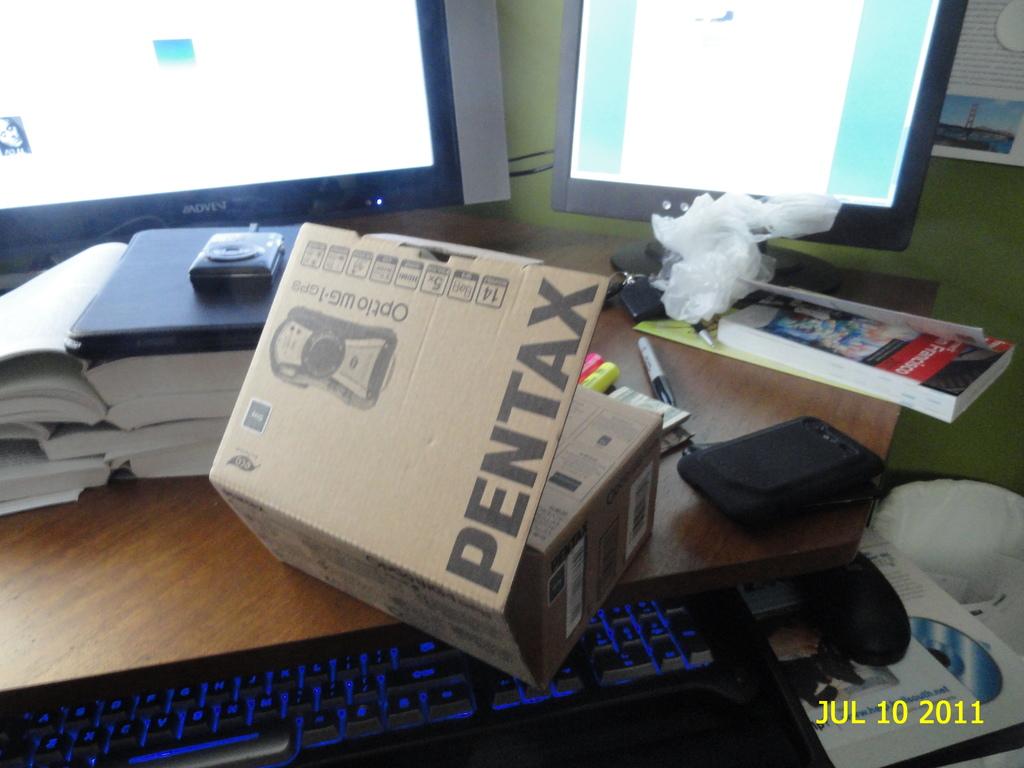What product is in the box?
Your answer should be compact. Pentax. What is the company who makes the product in the box printed in giant black letters?
Your response must be concise. Pentax. 